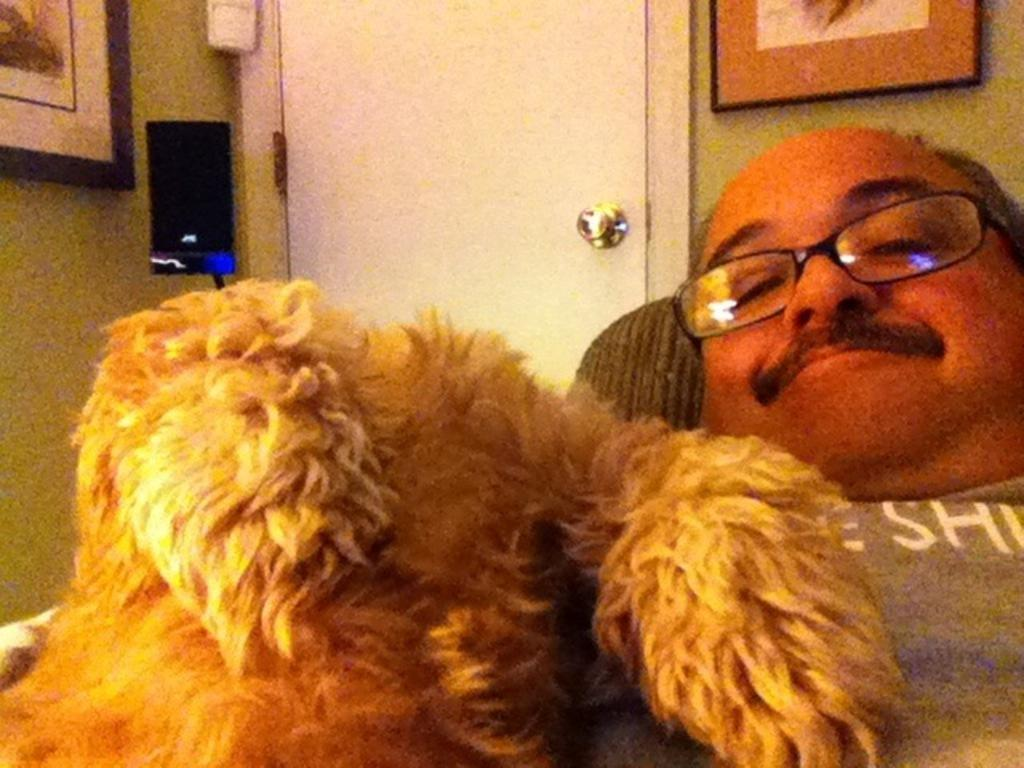Who is present in the image? There is a man in the image. What is the man doing in the image? The man is smiling in the image. What accessory is the man wearing? The man is wearing spectacles in the image. What animal is beside the man? There is a dog beside the man in the image. What can be seen on the wall in the background? There are frames on the wall in the background of the image. What architectural feature is visible in the background? There is a door in the background of the image. How many ladybugs are crawling on the man's spectacles in the image? There are no ladybugs present on the man's spectacles in the image. What type of straw is the man using to drink in the image? There is no straw visible in the image, and the man is not drinking. 